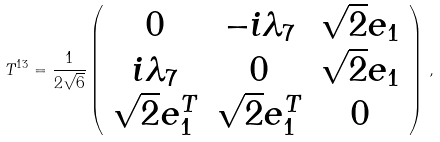<formula> <loc_0><loc_0><loc_500><loc_500>T ^ { 1 3 } = \frac { 1 } { 2 \sqrt { 6 } } \left ( \begin{array} { c c c } 0 & - i \lambda _ { 7 } & \sqrt { 2 } e _ { 1 } \\ i \lambda _ { 7 } & 0 & \sqrt { 2 } e _ { 1 } \\ \sqrt { 2 } e _ { 1 } ^ { T } & \sqrt { 2 } e _ { 1 } ^ { T } & 0 \end{array} \right ) \, ,</formula> 